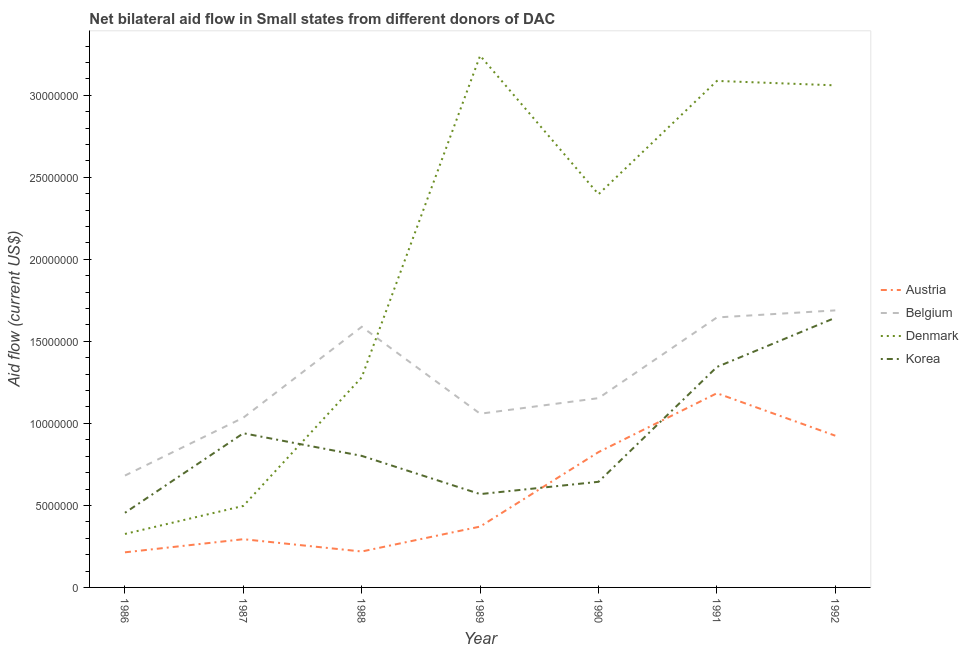Does the line corresponding to amount of aid given by korea intersect with the line corresponding to amount of aid given by austria?
Provide a short and direct response. Yes. What is the amount of aid given by korea in 1990?
Your answer should be very brief. 6.44e+06. Across all years, what is the maximum amount of aid given by belgium?
Your answer should be compact. 1.69e+07. Across all years, what is the minimum amount of aid given by belgium?
Provide a short and direct response. 6.82e+06. In which year was the amount of aid given by korea maximum?
Your answer should be compact. 1992. What is the total amount of aid given by austria in the graph?
Offer a very short reply. 4.03e+07. What is the difference between the amount of aid given by korea in 1988 and that in 1990?
Give a very brief answer. 1.58e+06. What is the difference between the amount of aid given by austria in 1989 and the amount of aid given by belgium in 1991?
Keep it short and to the point. -1.28e+07. What is the average amount of aid given by denmark per year?
Give a very brief answer. 1.98e+07. In the year 1989, what is the difference between the amount of aid given by austria and amount of aid given by korea?
Keep it short and to the point. -1.98e+06. In how many years, is the amount of aid given by korea greater than 25000000 US$?
Make the answer very short. 0. What is the ratio of the amount of aid given by austria in 1987 to that in 1991?
Your answer should be compact. 0.25. Is the amount of aid given by belgium in 1990 less than that in 1991?
Make the answer very short. Yes. What is the difference between the highest and the lowest amount of aid given by denmark?
Provide a short and direct response. 2.92e+07. In how many years, is the amount of aid given by korea greater than the average amount of aid given by korea taken over all years?
Provide a short and direct response. 3. Is it the case that in every year, the sum of the amount of aid given by belgium and amount of aid given by austria is greater than the sum of amount of aid given by korea and amount of aid given by denmark?
Your answer should be compact. No. Does the amount of aid given by denmark monotonically increase over the years?
Your answer should be very brief. No. Is the amount of aid given by belgium strictly greater than the amount of aid given by korea over the years?
Give a very brief answer. Yes. How many lines are there?
Your answer should be compact. 4. What is the difference between two consecutive major ticks on the Y-axis?
Provide a succinct answer. 5.00e+06. Does the graph contain any zero values?
Your response must be concise. No. Does the graph contain grids?
Your answer should be very brief. No. Where does the legend appear in the graph?
Make the answer very short. Center right. What is the title of the graph?
Your answer should be very brief. Net bilateral aid flow in Small states from different donors of DAC. Does "Rule based governance" appear as one of the legend labels in the graph?
Provide a short and direct response. No. What is the Aid flow (current US$) in Austria in 1986?
Your answer should be compact. 2.14e+06. What is the Aid flow (current US$) in Belgium in 1986?
Ensure brevity in your answer.  6.82e+06. What is the Aid flow (current US$) of Denmark in 1986?
Your answer should be very brief. 3.26e+06. What is the Aid flow (current US$) in Korea in 1986?
Ensure brevity in your answer.  4.55e+06. What is the Aid flow (current US$) of Austria in 1987?
Your response must be concise. 2.94e+06. What is the Aid flow (current US$) of Belgium in 1987?
Offer a very short reply. 1.04e+07. What is the Aid flow (current US$) of Denmark in 1987?
Make the answer very short. 4.97e+06. What is the Aid flow (current US$) of Korea in 1987?
Your response must be concise. 9.40e+06. What is the Aid flow (current US$) of Austria in 1988?
Ensure brevity in your answer.  2.19e+06. What is the Aid flow (current US$) in Belgium in 1988?
Provide a short and direct response. 1.59e+07. What is the Aid flow (current US$) in Denmark in 1988?
Provide a short and direct response. 1.28e+07. What is the Aid flow (current US$) of Korea in 1988?
Ensure brevity in your answer.  8.02e+06. What is the Aid flow (current US$) in Austria in 1989?
Give a very brief answer. 3.71e+06. What is the Aid flow (current US$) in Belgium in 1989?
Make the answer very short. 1.06e+07. What is the Aid flow (current US$) in Denmark in 1989?
Provide a short and direct response. 3.24e+07. What is the Aid flow (current US$) in Korea in 1989?
Make the answer very short. 5.69e+06. What is the Aid flow (current US$) in Austria in 1990?
Make the answer very short. 8.25e+06. What is the Aid flow (current US$) in Belgium in 1990?
Your response must be concise. 1.15e+07. What is the Aid flow (current US$) in Denmark in 1990?
Offer a terse response. 2.40e+07. What is the Aid flow (current US$) of Korea in 1990?
Your answer should be very brief. 6.44e+06. What is the Aid flow (current US$) of Austria in 1991?
Keep it short and to the point. 1.18e+07. What is the Aid flow (current US$) of Belgium in 1991?
Keep it short and to the point. 1.65e+07. What is the Aid flow (current US$) of Denmark in 1991?
Give a very brief answer. 3.09e+07. What is the Aid flow (current US$) in Korea in 1991?
Offer a terse response. 1.34e+07. What is the Aid flow (current US$) of Austria in 1992?
Keep it short and to the point. 9.25e+06. What is the Aid flow (current US$) in Belgium in 1992?
Your response must be concise. 1.69e+07. What is the Aid flow (current US$) in Denmark in 1992?
Your answer should be very brief. 3.06e+07. What is the Aid flow (current US$) of Korea in 1992?
Give a very brief answer. 1.64e+07. Across all years, what is the maximum Aid flow (current US$) in Austria?
Provide a succinct answer. 1.18e+07. Across all years, what is the maximum Aid flow (current US$) of Belgium?
Offer a very short reply. 1.69e+07. Across all years, what is the maximum Aid flow (current US$) of Denmark?
Keep it short and to the point. 3.24e+07. Across all years, what is the maximum Aid flow (current US$) in Korea?
Offer a very short reply. 1.64e+07. Across all years, what is the minimum Aid flow (current US$) of Austria?
Ensure brevity in your answer.  2.14e+06. Across all years, what is the minimum Aid flow (current US$) of Belgium?
Offer a very short reply. 6.82e+06. Across all years, what is the minimum Aid flow (current US$) in Denmark?
Make the answer very short. 3.26e+06. Across all years, what is the minimum Aid flow (current US$) of Korea?
Give a very brief answer. 4.55e+06. What is the total Aid flow (current US$) in Austria in the graph?
Make the answer very short. 4.03e+07. What is the total Aid flow (current US$) of Belgium in the graph?
Provide a succinct answer. 8.85e+07. What is the total Aid flow (current US$) in Denmark in the graph?
Ensure brevity in your answer.  1.39e+08. What is the total Aid flow (current US$) of Korea in the graph?
Make the answer very short. 6.40e+07. What is the difference between the Aid flow (current US$) in Austria in 1986 and that in 1987?
Keep it short and to the point. -8.00e+05. What is the difference between the Aid flow (current US$) in Belgium in 1986 and that in 1987?
Give a very brief answer. -3.53e+06. What is the difference between the Aid flow (current US$) of Denmark in 1986 and that in 1987?
Offer a terse response. -1.71e+06. What is the difference between the Aid flow (current US$) of Korea in 1986 and that in 1987?
Keep it short and to the point. -4.85e+06. What is the difference between the Aid flow (current US$) of Belgium in 1986 and that in 1988?
Provide a succinct answer. -9.07e+06. What is the difference between the Aid flow (current US$) of Denmark in 1986 and that in 1988?
Your answer should be compact. -9.55e+06. What is the difference between the Aid flow (current US$) of Korea in 1986 and that in 1988?
Keep it short and to the point. -3.47e+06. What is the difference between the Aid flow (current US$) of Austria in 1986 and that in 1989?
Provide a short and direct response. -1.57e+06. What is the difference between the Aid flow (current US$) of Belgium in 1986 and that in 1989?
Make the answer very short. -3.77e+06. What is the difference between the Aid flow (current US$) of Denmark in 1986 and that in 1989?
Offer a terse response. -2.92e+07. What is the difference between the Aid flow (current US$) in Korea in 1986 and that in 1989?
Offer a very short reply. -1.14e+06. What is the difference between the Aid flow (current US$) in Austria in 1986 and that in 1990?
Make the answer very short. -6.11e+06. What is the difference between the Aid flow (current US$) of Belgium in 1986 and that in 1990?
Offer a terse response. -4.72e+06. What is the difference between the Aid flow (current US$) of Denmark in 1986 and that in 1990?
Your response must be concise. -2.07e+07. What is the difference between the Aid flow (current US$) of Korea in 1986 and that in 1990?
Provide a succinct answer. -1.89e+06. What is the difference between the Aid flow (current US$) of Austria in 1986 and that in 1991?
Offer a terse response. -9.70e+06. What is the difference between the Aid flow (current US$) in Belgium in 1986 and that in 1991?
Ensure brevity in your answer.  -9.64e+06. What is the difference between the Aid flow (current US$) in Denmark in 1986 and that in 1991?
Provide a short and direct response. -2.76e+07. What is the difference between the Aid flow (current US$) of Korea in 1986 and that in 1991?
Give a very brief answer. -8.89e+06. What is the difference between the Aid flow (current US$) in Austria in 1986 and that in 1992?
Your answer should be compact. -7.11e+06. What is the difference between the Aid flow (current US$) in Belgium in 1986 and that in 1992?
Offer a terse response. -1.01e+07. What is the difference between the Aid flow (current US$) in Denmark in 1986 and that in 1992?
Your answer should be very brief. -2.74e+07. What is the difference between the Aid flow (current US$) of Korea in 1986 and that in 1992?
Make the answer very short. -1.19e+07. What is the difference between the Aid flow (current US$) of Austria in 1987 and that in 1988?
Provide a short and direct response. 7.50e+05. What is the difference between the Aid flow (current US$) in Belgium in 1987 and that in 1988?
Provide a short and direct response. -5.54e+06. What is the difference between the Aid flow (current US$) in Denmark in 1987 and that in 1988?
Offer a terse response. -7.84e+06. What is the difference between the Aid flow (current US$) in Korea in 1987 and that in 1988?
Ensure brevity in your answer.  1.38e+06. What is the difference between the Aid flow (current US$) in Austria in 1987 and that in 1989?
Your answer should be very brief. -7.70e+05. What is the difference between the Aid flow (current US$) in Belgium in 1987 and that in 1989?
Give a very brief answer. -2.40e+05. What is the difference between the Aid flow (current US$) of Denmark in 1987 and that in 1989?
Provide a succinct answer. -2.74e+07. What is the difference between the Aid flow (current US$) in Korea in 1987 and that in 1989?
Ensure brevity in your answer.  3.71e+06. What is the difference between the Aid flow (current US$) of Austria in 1987 and that in 1990?
Your response must be concise. -5.31e+06. What is the difference between the Aid flow (current US$) in Belgium in 1987 and that in 1990?
Make the answer very short. -1.19e+06. What is the difference between the Aid flow (current US$) in Denmark in 1987 and that in 1990?
Your answer should be compact. -1.90e+07. What is the difference between the Aid flow (current US$) in Korea in 1987 and that in 1990?
Keep it short and to the point. 2.96e+06. What is the difference between the Aid flow (current US$) in Austria in 1987 and that in 1991?
Make the answer very short. -8.90e+06. What is the difference between the Aid flow (current US$) of Belgium in 1987 and that in 1991?
Give a very brief answer. -6.11e+06. What is the difference between the Aid flow (current US$) in Denmark in 1987 and that in 1991?
Give a very brief answer. -2.59e+07. What is the difference between the Aid flow (current US$) of Korea in 1987 and that in 1991?
Keep it short and to the point. -4.04e+06. What is the difference between the Aid flow (current US$) of Austria in 1987 and that in 1992?
Your response must be concise. -6.31e+06. What is the difference between the Aid flow (current US$) of Belgium in 1987 and that in 1992?
Ensure brevity in your answer.  -6.54e+06. What is the difference between the Aid flow (current US$) of Denmark in 1987 and that in 1992?
Offer a terse response. -2.56e+07. What is the difference between the Aid flow (current US$) of Korea in 1987 and that in 1992?
Provide a succinct answer. -7.04e+06. What is the difference between the Aid flow (current US$) of Austria in 1988 and that in 1989?
Your response must be concise. -1.52e+06. What is the difference between the Aid flow (current US$) in Belgium in 1988 and that in 1989?
Your answer should be very brief. 5.30e+06. What is the difference between the Aid flow (current US$) in Denmark in 1988 and that in 1989?
Offer a terse response. -1.96e+07. What is the difference between the Aid flow (current US$) in Korea in 1988 and that in 1989?
Give a very brief answer. 2.33e+06. What is the difference between the Aid flow (current US$) of Austria in 1988 and that in 1990?
Make the answer very short. -6.06e+06. What is the difference between the Aid flow (current US$) in Belgium in 1988 and that in 1990?
Offer a terse response. 4.35e+06. What is the difference between the Aid flow (current US$) in Denmark in 1988 and that in 1990?
Ensure brevity in your answer.  -1.12e+07. What is the difference between the Aid flow (current US$) of Korea in 1988 and that in 1990?
Your response must be concise. 1.58e+06. What is the difference between the Aid flow (current US$) of Austria in 1988 and that in 1991?
Offer a terse response. -9.65e+06. What is the difference between the Aid flow (current US$) in Belgium in 1988 and that in 1991?
Keep it short and to the point. -5.70e+05. What is the difference between the Aid flow (current US$) in Denmark in 1988 and that in 1991?
Keep it short and to the point. -1.81e+07. What is the difference between the Aid flow (current US$) of Korea in 1988 and that in 1991?
Offer a terse response. -5.42e+06. What is the difference between the Aid flow (current US$) of Austria in 1988 and that in 1992?
Your answer should be very brief. -7.06e+06. What is the difference between the Aid flow (current US$) in Denmark in 1988 and that in 1992?
Your answer should be very brief. -1.78e+07. What is the difference between the Aid flow (current US$) of Korea in 1988 and that in 1992?
Keep it short and to the point. -8.42e+06. What is the difference between the Aid flow (current US$) in Austria in 1989 and that in 1990?
Provide a short and direct response. -4.54e+06. What is the difference between the Aid flow (current US$) in Belgium in 1989 and that in 1990?
Your response must be concise. -9.50e+05. What is the difference between the Aid flow (current US$) in Denmark in 1989 and that in 1990?
Ensure brevity in your answer.  8.45e+06. What is the difference between the Aid flow (current US$) in Korea in 1989 and that in 1990?
Provide a succinct answer. -7.50e+05. What is the difference between the Aid flow (current US$) in Austria in 1989 and that in 1991?
Ensure brevity in your answer.  -8.13e+06. What is the difference between the Aid flow (current US$) in Belgium in 1989 and that in 1991?
Offer a terse response. -5.87e+06. What is the difference between the Aid flow (current US$) of Denmark in 1989 and that in 1991?
Your response must be concise. 1.54e+06. What is the difference between the Aid flow (current US$) in Korea in 1989 and that in 1991?
Offer a very short reply. -7.75e+06. What is the difference between the Aid flow (current US$) in Austria in 1989 and that in 1992?
Your answer should be compact. -5.54e+06. What is the difference between the Aid flow (current US$) of Belgium in 1989 and that in 1992?
Your answer should be very brief. -6.30e+06. What is the difference between the Aid flow (current US$) of Denmark in 1989 and that in 1992?
Make the answer very short. 1.81e+06. What is the difference between the Aid flow (current US$) of Korea in 1989 and that in 1992?
Ensure brevity in your answer.  -1.08e+07. What is the difference between the Aid flow (current US$) in Austria in 1990 and that in 1991?
Offer a very short reply. -3.59e+06. What is the difference between the Aid flow (current US$) in Belgium in 1990 and that in 1991?
Your response must be concise. -4.92e+06. What is the difference between the Aid flow (current US$) in Denmark in 1990 and that in 1991?
Your answer should be compact. -6.91e+06. What is the difference between the Aid flow (current US$) of Korea in 1990 and that in 1991?
Keep it short and to the point. -7.00e+06. What is the difference between the Aid flow (current US$) in Austria in 1990 and that in 1992?
Provide a succinct answer. -1.00e+06. What is the difference between the Aid flow (current US$) of Belgium in 1990 and that in 1992?
Your answer should be compact. -5.35e+06. What is the difference between the Aid flow (current US$) in Denmark in 1990 and that in 1992?
Provide a short and direct response. -6.64e+06. What is the difference between the Aid flow (current US$) in Korea in 1990 and that in 1992?
Provide a succinct answer. -1.00e+07. What is the difference between the Aid flow (current US$) of Austria in 1991 and that in 1992?
Your response must be concise. 2.59e+06. What is the difference between the Aid flow (current US$) of Belgium in 1991 and that in 1992?
Provide a short and direct response. -4.30e+05. What is the difference between the Aid flow (current US$) of Denmark in 1991 and that in 1992?
Give a very brief answer. 2.70e+05. What is the difference between the Aid flow (current US$) in Korea in 1991 and that in 1992?
Make the answer very short. -3.00e+06. What is the difference between the Aid flow (current US$) of Austria in 1986 and the Aid flow (current US$) of Belgium in 1987?
Ensure brevity in your answer.  -8.21e+06. What is the difference between the Aid flow (current US$) of Austria in 1986 and the Aid flow (current US$) of Denmark in 1987?
Give a very brief answer. -2.83e+06. What is the difference between the Aid flow (current US$) of Austria in 1986 and the Aid flow (current US$) of Korea in 1987?
Make the answer very short. -7.26e+06. What is the difference between the Aid flow (current US$) in Belgium in 1986 and the Aid flow (current US$) in Denmark in 1987?
Give a very brief answer. 1.85e+06. What is the difference between the Aid flow (current US$) of Belgium in 1986 and the Aid flow (current US$) of Korea in 1987?
Provide a short and direct response. -2.58e+06. What is the difference between the Aid flow (current US$) of Denmark in 1986 and the Aid flow (current US$) of Korea in 1987?
Offer a very short reply. -6.14e+06. What is the difference between the Aid flow (current US$) in Austria in 1986 and the Aid flow (current US$) in Belgium in 1988?
Make the answer very short. -1.38e+07. What is the difference between the Aid flow (current US$) of Austria in 1986 and the Aid flow (current US$) of Denmark in 1988?
Keep it short and to the point. -1.07e+07. What is the difference between the Aid flow (current US$) in Austria in 1986 and the Aid flow (current US$) in Korea in 1988?
Give a very brief answer. -5.88e+06. What is the difference between the Aid flow (current US$) in Belgium in 1986 and the Aid flow (current US$) in Denmark in 1988?
Ensure brevity in your answer.  -5.99e+06. What is the difference between the Aid flow (current US$) in Belgium in 1986 and the Aid flow (current US$) in Korea in 1988?
Your answer should be compact. -1.20e+06. What is the difference between the Aid flow (current US$) of Denmark in 1986 and the Aid flow (current US$) of Korea in 1988?
Your response must be concise. -4.76e+06. What is the difference between the Aid flow (current US$) in Austria in 1986 and the Aid flow (current US$) in Belgium in 1989?
Give a very brief answer. -8.45e+06. What is the difference between the Aid flow (current US$) in Austria in 1986 and the Aid flow (current US$) in Denmark in 1989?
Make the answer very short. -3.03e+07. What is the difference between the Aid flow (current US$) in Austria in 1986 and the Aid flow (current US$) in Korea in 1989?
Provide a short and direct response. -3.55e+06. What is the difference between the Aid flow (current US$) of Belgium in 1986 and the Aid flow (current US$) of Denmark in 1989?
Keep it short and to the point. -2.56e+07. What is the difference between the Aid flow (current US$) in Belgium in 1986 and the Aid flow (current US$) in Korea in 1989?
Keep it short and to the point. 1.13e+06. What is the difference between the Aid flow (current US$) of Denmark in 1986 and the Aid flow (current US$) of Korea in 1989?
Give a very brief answer. -2.43e+06. What is the difference between the Aid flow (current US$) in Austria in 1986 and the Aid flow (current US$) in Belgium in 1990?
Offer a terse response. -9.40e+06. What is the difference between the Aid flow (current US$) of Austria in 1986 and the Aid flow (current US$) of Denmark in 1990?
Your answer should be very brief. -2.18e+07. What is the difference between the Aid flow (current US$) in Austria in 1986 and the Aid flow (current US$) in Korea in 1990?
Provide a succinct answer. -4.30e+06. What is the difference between the Aid flow (current US$) of Belgium in 1986 and the Aid flow (current US$) of Denmark in 1990?
Provide a short and direct response. -1.72e+07. What is the difference between the Aid flow (current US$) in Belgium in 1986 and the Aid flow (current US$) in Korea in 1990?
Your response must be concise. 3.80e+05. What is the difference between the Aid flow (current US$) in Denmark in 1986 and the Aid flow (current US$) in Korea in 1990?
Your answer should be very brief. -3.18e+06. What is the difference between the Aid flow (current US$) of Austria in 1986 and the Aid flow (current US$) of Belgium in 1991?
Your response must be concise. -1.43e+07. What is the difference between the Aid flow (current US$) in Austria in 1986 and the Aid flow (current US$) in Denmark in 1991?
Make the answer very short. -2.87e+07. What is the difference between the Aid flow (current US$) of Austria in 1986 and the Aid flow (current US$) of Korea in 1991?
Keep it short and to the point. -1.13e+07. What is the difference between the Aid flow (current US$) in Belgium in 1986 and the Aid flow (current US$) in Denmark in 1991?
Your response must be concise. -2.41e+07. What is the difference between the Aid flow (current US$) of Belgium in 1986 and the Aid flow (current US$) of Korea in 1991?
Provide a short and direct response. -6.62e+06. What is the difference between the Aid flow (current US$) in Denmark in 1986 and the Aid flow (current US$) in Korea in 1991?
Give a very brief answer. -1.02e+07. What is the difference between the Aid flow (current US$) of Austria in 1986 and the Aid flow (current US$) of Belgium in 1992?
Provide a short and direct response. -1.48e+07. What is the difference between the Aid flow (current US$) in Austria in 1986 and the Aid flow (current US$) in Denmark in 1992?
Your answer should be very brief. -2.85e+07. What is the difference between the Aid flow (current US$) in Austria in 1986 and the Aid flow (current US$) in Korea in 1992?
Give a very brief answer. -1.43e+07. What is the difference between the Aid flow (current US$) of Belgium in 1986 and the Aid flow (current US$) of Denmark in 1992?
Provide a succinct answer. -2.38e+07. What is the difference between the Aid flow (current US$) in Belgium in 1986 and the Aid flow (current US$) in Korea in 1992?
Make the answer very short. -9.62e+06. What is the difference between the Aid flow (current US$) in Denmark in 1986 and the Aid flow (current US$) in Korea in 1992?
Provide a short and direct response. -1.32e+07. What is the difference between the Aid flow (current US$) of Austria in 1987 and the Aid flow (current US$) of Belgium in 1988?
Give a very brief answer. -1.30e+07. What is the difference between the Aid flow (current US$) in Austria in 1987 and the Aid flow (current US$) in Denmark in 1988?
Ensure brevity in your answer.  -9.87e+06. What is the difference between the Aid flow (current US$) of Austria in 1987 and the Aid flow (current US$) of Korea in 1988?
Provide a succinct answer. -5.08e+06. What is the difference between the Aid flow (current US$) in Belgium in 1987 and the Aid flow (current US$) in Denmark in 1988?
Your answer should be very brief. -2.46e+06. What is the difference between the Aid flow (current US$) of Belgium in 1987 and the Aid flow (current US$) of Korea in 1988?
Provide a succinct answer. 2.33e+06. What is the difference between the Aid flow (current US$) of Denmark in 1987 and the Aid flow (current US$) of Korea in 1988?
Your response must be concise. -3.05e+06. What is the difference between the Aid flow (current US$) in Austria in 1987 and the Aid flow (current US$) in Belgium in 1989?
Make the answer very short. -7.65e+06. What is the difference between the Aid flow (current US$) in Austria in 1987 and the Aid flow (current US$) in Denmark in 1989?
Your answer should be compact. -2.95e+07. What is the difference between the Aid flow (current US$) of Austria in 1987 and the Aid flow (current US$) of Korea in 1989?
Provide a short and direct response. -2.75e+06. What is the difference between the Aid flow (current US$) in Belgium in 1987 and the Aid flow (current US$) in Denmark in 1989?
Your response must be concise. -2.21e+07. What is the difference between the Aid flow (current US$) in Belgium in 1987 and the Aid flow (current US$) in Korea in 1989?
Keep it short and to the point. 4.66e+06. What is the difference between the Aid flow (current US$) of Denmark in 1987 and the Aid flow (current US$) of Korea in 1989?
Ensure brevity in your answer.  -7.20e+05. What is the difference between the Aid flow (current US$) in Austria in 1987 and the Aid flow (current US$) in Belgium in 1990?
Keep it short and to the point. -8.60e+06. What is the difference between the Aid flow (current US$) of Austria in 1987 and the Aid flow (current US$) of Denmark in 1990?
Keep it short and to the point. -2.10e+07. What is the difference between the Aid flow (current US$) of Austria in 1987 and the Aid flow (current US$) of Korea in 1990?
Make the answer very short. -3.50e+06. What is the difference between the Aid flow (current US$) of Belgium in 1987 and the Aid flow (current US$) of Denmark in 1990?
Keep it short and to the point. -1.36e+07. What is the difference between the Aid flow (current US$) of Belgium in 1987 and the Aid flow (current US$) of Korea in 1990?
Your response must be concise. 3.91e+06. What is the difference between the Aid flow (current US$) of Denmark in 1987 and the Aid flow (current US$) of Korea in 1990?
Ensure brevity in your answer.  -1.47e+06. What is the difference between the Aid flow (current US$) in Austria in 1987 and the Aid flow (current US$) in Belgium in 1991?
Give a very brief answer. -1.35e+07. What is the difference between the Aid flow (current US$) in Austria in 1987 and the Aid flow (current US$) in Denmark in 1991?
Keep it short and to the point. -2.79e+07. What is the difference between the Aid flow (current US$) of Austria in 1987 and the Aid flow (current US$) of Korea in 1991?
Keep it short and to the point. -1.05e+07. What is the difference between the Aid flow (current US$) of Belgium in 1987 and the Aid flow (current US$) of Denmark in 1991?
Offer a very short reply. -2.05e+07. What is the difference between the Aid flow (current US$) of Belgium in 1987 and the Aid flow (current US$) of Korea in 1991?
Provide a succinct answer. -3.09e+06. What is the difference between the Aid flow (current US$) of Denmark in 1987 and the Aid flow (current US$) of Korea in 1991?
Make the answer very short. -8.47e+06. What is the difference between the Aid flow (current US$) of Austria in 1987 and the Aid flow (current US$) of Belgium in 1992?
Your answer should be compact. -1.40e+07. What is the difference between the Aid flow (current US$) in Austria in 1987 and the Aid flow (current US$) in Denmark in 1992?
Your answer should be compact. -2.77e+07. What is the difference between the Aid flow (current US$) of Austria in 1987 and the Aid flow (current US$) of Korea in 1992?
Your response must be concise. -1.35e+07. What is the difference between the Aid flow (current US$) of Belgium in 1987 and the Aid flow (current US$) of Denmark in 1992?
Your answer should be compact. -2.03e+07. What is the difference between the Aid flow (current US$) in Belgium in 1987 and the Aid flow (current US$) in Korea in 1992?
Your response must be concise. -6.09e+06. What is the difference between the Aid flow (current US$) in Denmark in 1987 and the Aid flow (current US$) in Korea in 1992?
Ensure brevity in your answer.  -1.15e+07. What is the difference between the Aid flow (current US$) in Austria in 1988 and the Aid flow (current US$) in Belgium in 1989?
Offer a very short reply. -8.40e+06. What is the difference between the Aid flow (current US$) in Austria in 1988 and the Aid flow (current US$) in Denmark in 1989?
Keep it short and to the point. -3.02e+07. What is the difference between the Aid flow (current US$) of Austria in 1988 and the Aid flow (current US$) of Korea in 1989?
Give a very brief answer. -3.50e+06. What is the difference between the Aid flow (current US$) in Belgium in 1988 and the Aid flow (current US$) in Denmark in 1989?
Offer a very short reply. -1.65e+07. What is the difference between the Aid flow (current US$) in Belgium in 1988 and the Aid flow (current US$) in Korea in 1989?
Give a very brief answer. 1.02e+07. What is the difference between the Aid flow (current US$) of Denmark in 1988 and the Aid flow (current US$) of Korea in 1989?
Keep it short and to the point. 7.12e+06. What is the difference between the Aid flow (current US$) in Austria in 1988 and the Aid flow (current US$) in Belgium in 1990?
Offer a terse response. -9.35e+06. What is the difference between the Aid flow (current US$) in Austria in 1988 and the Aid flow (current US$) in Denmark in 1990?
Give a very brief answer. -2.18e+07. What is the difference between the Aid flow (current US$) of Austria in 1988 and the Aid flow (current US$) of Korea in 1990?
Your answer should be very brief. -4.25e+06. What is the difference between the Aid flow (current US$) in Belgium in 1988 and the Aid flow (current US$) in Denmark in 1990?
Make the answer very short. -8.08e+06. What is the difference between the Aid flow (current US$) in Belgium in 1988 and the Aid flow (current US$) in Korea in 1990?
Offer a very short reply. 9.45e+06. What is the difference between the Aid flow (current US$) of Denmark in 1988 and the Aid flow (current US$) of Korea in 1990?
Your answer should be compact. 6.37e+06. What is the difference between the Aid flow (current US$) in Austria in 1988 and the Aid flow (current US$) in Belgium in 1991?
Your answer should be compact. -1.43e+07. What is the difference between the Aid flow (current US$) in Austria in 1988 and the Aid flow (current US$) in Denmark in 1991?
Make the answer very short. -2.87e+07. What is the difference between the Aid flow (current US$) in Austria in 1988 and the Aid flow (current US$) in Korea in 1991?
Your response must be concise. -1.12e+07. What is the difference between the Aid flow (current US$) in Belgium in 1988 and the Aid flow (current US$) in Denmark in 1991?
Your answer should be compact. -1.50e+07. What is the difference between the Aid flow (current US$) in Belgium in 1988 and the Aid flow (current US$) in Korea in 1991?
Give a very brief answer. 2.45e+06. What is the difference between the Aid flow (current US$) in Denmark in 1988 and the Aid flow (current US$) in Korea in 1991?
Offer a very short reply. -6.30e+05. What is the difference between the Aid flow (current US$) in Austria in 1988 and the Aid flow (current US$) in Belgium in 1992?
Your response must be concise. -1.47e+07. What is the difference between the Aid flow (current US$) of Austria in 1988 and the Aid flow (current US$) of Denmark in 1992?
Keep it short and to the point. -2.84e+07. What is the difference between the Aid flow (current US$) in Austria in 1988 and the Aid flow (current US$) in Korea in 1992?
Make the answer very short. -1.42e+07. What is the difference between the Aid flow (current US$) in Belgium in 1988 and the Aid flow (current US$) in Denmark in 1992?
Give a very brief answer. -1.47e+07. What is the difference between the Aid flow (current US$) of Belgium in 1988 and the Aid flow (current US$) of Korea in 1992?
Make the answer very short. -5.50e+05. What is the difference between the Aid flow (current US$) of Denmark in 1988 and the Aid flow (current US$) of Korea in 1992?
Your answer should be compact. -3.63e+06. What is the difference between the Aid flow (current US$) in Austria in 1989 and the Aid flow (current US$) in Belgium in 1990?
Your answer should be compact. -7.83e+06. What is the difference between the Aid flow (current US$) of Austria in 1989 and the Aid flow (current US$) of Denmark in 1990?
Your response must be concise. -2.03e+07. What is the difference between the Aid flow (current US$) of Austria in 1989 and the Aid flow (current US$) of Korea in 1990?
Your answer should be very brief. -2.73e+06. What is the difference between the Aid flow (current US$) in Belgium in 1989 and the Aid flow (current US$) in Denmark in 1990?
Give a very brief answer. -1.34e+07. What is the difference between the Aid flow (current US$) of Belgium in 1989 and the Aid flow (current US$) of Korea in 1990?
Give a very brief answer. 4.15e+06. What is the difference between the Aid flow (current US$) of Denmark in 1989 and the Aid flow (current US$) of Korea in 1990?
Give a very brief answer. 2.60e+07. What is the difference between the Aid flow (current US$) of Austria in 1989 and the Aid flow (current US$) of Belgium in 1991?
Your answer should be very brief. -1.28e+07. What is the difference between the Aid flow (current US$) of Austria in 1989 and the Aid flow (current US$) of Denmark in 1991?
Provide a short and direct response. -2.72e+07. What is the difference between the Aid flow (current US$) in Austria in 1989 and the Aid flow (current US$) in Korea in 1991?
Give a very brief answer. -9.73e+06. What is the difference between the Aid flow (current US$) of Belgium in 1989 and the Aid flow (current US$) of Denmark in 1991?
Your response must be concise. -2.03e+07. What is the difference between the Aid flow (current US$) in Belgium in 1989 and the Aid flow (current US$) in Korea in 1991?
Your response must be concise. -2.85e+06. What is the difference between the Aid flow (current US$) of Denmark in 1989 and the Aid flow (current US$) of Korea in 1991?
Make the answer very short. 1.90e+07. What is the difference between the Aid flow (current US$) in Austria in 1989 and the Aid flow (current US$) in Belgium in 1992?
Make the answer very short. -1.32e+07. What is the difference between the Aid flow (current US$) of Austria in 1989 and the Aid flow (current US$) of Denmark in 1992?
Your answer should be compact. -2.69e+07. What is the difference between the Aid flow (current US$) of Austria in 1989 and the Aid flow (current US$) of Korea in 1992?
Offer a very short reply. -1.27e+07. What is the difference between the Aid flow (current US$) in Belgium in 1989 and the Aid flow (current US$) in Denmark in 1992?
Your answer should be very brief. -2.00e+07. What is the difference between the Aid flow (current US$) in Belgium in 1989 and the Aid flow (current US$) in Korea in 1992?
Your answer should be compact. -5.85e+06. What is the difference between the Aid flow (current US$) in Denmark in 1989 and the Aid flow (current US$) in Korea in 1992?
Ensure brevity in your answer.  1.60e+07. What is the difference between the Aid flow (current US$) in Austria in 1990 and the Aid flow (current US$) in Belgium in 1991?
Keep it short and to the point. -8.21e+06. What is the difference between the Aid flow (current US$) of Austria in 1990 and the Aid flow (current US$) of Denmark in 1991?
Give a very brief answer. -2.26e+07. What is the difference between the Aid flow (current US$) in Austria in 1990 and the Aid flow (current US$) in Korea in 1991?
Give a very brief answer. -5.19e+06. What is the difference between the Aid flow (current US$) of Belgium in 1990 and the Aid flow (current US$) of Denmark in 1991?
Give a very brief answer. -1.93e+07. What is the difference between the Aid flow (current US$) of Belgium in 1990 and the Aid flow (current US$) of Korea in 1991?
Keep it short and to the point. -1.90e+06. What is the difference between the Aid flow (current US$) of Denmark in 1990 and the Aid flow (current US$) of Korea in 1991?
Your answer should be very brief. 1.05e+07. What is the difference between the Aid flow (current US$) in Austria in 1990 and the Aid flow (current US$) in Belgium in 1992?
Give a very brief answer. -8.64e+06. What is the difference between the Aid flow (current US$) in Austria in 1990 and the Aid flow (current US$) in Denmark in 1992?
Provide a short and direct response. -2.24e+07. What is the difference between the Aid flow (current US$) of Austria in 1990 and the Aid flow (current US$) of Korea in 1992?
Your response must be concise. -8.19e+06. What is the difference between the Aid flow (current US$) in Belgium in 1990 and the Aid flow (current US$) in Denmark in 1992?
Make the answer very short. -1.91e+07. What is the difference between the Aid flow (current US$) of Belgium in 1990 and the Aid flow (current US$) of Korea in 1992?
Offer a terse response. -4.90e+06. What is the difference between the Aid flow (current US$) of Denmark in 1990 and the Aid flow (current US$) of Korea in 1992?
Keep it short and to the point. 7.53e+06. What is the difference between the Aid flow (current US$) in Austria in 1991 and the Aid flow (current US$) in Belgium in 1992?
Provide a short and direct response. -5.05e+06. What is the difference between the Aid flow (current US$) in Austria in 1991 and the Aid flow (current US$) in Denmark in 1992?
Make the answer very short. -1.88e+07. What is the difference between the Aid flow (current US$) of Austria in 1991 and the Aid flow (current US$) of Korea in 1992?
Give a very brief answer. -4.60e+06. What is the difference between the Aid flow (current US$) in Belgium in 1991 and the Aid flow (current US$) in Denmark in 1992?
Provide a succinct answer. -1.42e+07. What is the difference between the Aid flow (current US$) in Belgium in 1991 and the Aid flow (current US$) in Korea in 1992?
Make the answer very short. 2.00e+04. What is the difference between the Aid flow (current US$) in Denmark in 1991 and the Aid flow (current US$) in Korea in 1992?
Provide a short and direct response. 1.44e+07. What is the average Aid flow (current US$) of Austria per year?
Your answer should be very brief. 5.76e+06. What is the average Aid flow (current US$) of Belgium per year?
Your answer should be compact. 1.26e+07. What is the average Aid flow (current US$) of Denmark per year?
Keep it short and to the point. 1.98e+07. What is the average Aid flow (current US$) in Korea per year?
Offer a terse response. 9.14e+06. In the year 1986, what is the difference between the Aid flow (current US$) of Austria and Aid flow (current US$) of Belgium?
Make the answer very short. -4.68e+06. In the year 1986, what is the difference between the Aid flow (current US$) in Austria and Aid flow (current US$) in Denmark?
Give a very brief answer. -1.12e+06. In the year 1986, what is the difference between the Aid flow (current US$) in Austria and Aid flow (current US$) in Korea?
Your answer should be very brief. -2.41e+06. In the year 1986, what is the difference between the Aid flow (current US$) of Belgium and Aid flow (current US$) of Denmark?
Provide a short and direct response. 3.56e+06. In the year 1986, what is the difference between the Aid flow (current US$) in Belgium and Aid flow (current US$) in Korea?
Give a very brief answer. 2.27e+06. In the year 1986, what is the difference between the Aid flow (current US$) in Denmark and Aid flow (current US$) in Korea?
Your response must be concise. -1.29e+06. In the year 1987, what is the difference between the Aid flow (current US$) in Austria and Aid flow (current US$) in Belgium?
Provide a succinct answer. -7.41e+06. In the year 1987, what is the difference between the Aid flow (current US$) in Austria and Aid flow (current US$) in Denmark?
Keep it short and to the point. -2.03e+06. In the year 1987, what is the difference between the Aid flow (current US$) in Austria and Aid flow (current US$) in Korea?
Your response must be concise. -6.46e+06. In the year 1987, what is the difference between the Aid flow (current US$) of Belgium and Aid flow (current US$) of Denmark?
Provide a short and direct response. 5.38e+06. In the year 1987, what is the difference between the Aid flow (current US$) of Belgium and Aid flow (current US$) of Korea?
Your answer should be very brief. 9.50e+05. In the year 1987, what is the difference between the Aid flow (current US$) of Denmark and Aid flow (current US$) of Korea?
Your answer should be compact. -4.43e+06. In the year 1988, what is the difference between the Aid flow (current US$) in Austria and Aid flow (current US$) in Belgium?
Ensure brevity in your answer.  -1.37e+07. In the year 1988, what is the difference between the Aid flow (current US$) of Austria and Aid flow (current US$) of Denmark?
Offer a terse response. -1.06e+07. In the year 1988, what is the difference between the Aid flow (current US$) in Austria and Aid flow (current US$) in Korea?
Provide a short and direct response. -5.83e+06. In the year 1988, what is the difference between the Aid flow (current US$) in Belgium and Aid flow (current US$) in Denmark?
Your answer should be compact. 3.08e+06. In the year 1988, what is the difference between the Aid flow (current US$) in Belgium and Aid flow (current US$) in Korea?
Your response must be concise. 7.87e+06. In the year 1988, what is the difference between the Aid flow (current US$) of Denmark and Aid flow (current US$) of Korea?
Your answer should be very brief. 4.79e+06. In the year 1989, what is the difference between the Aid flow (current US$) of Austria and Aid flow (current US$) of Belgium?
Keep it short and to the point. -6.88e+06. In the year 1989, what is the difference between the Aid flow (current US$) in Austria and Aid flow (current US$) in Denmark?
Your response must be concise. -2.87e+07. In the year 1989, what is the difference between the Aid flow (current US$) in Austria and Aid flow (current US$) in Korea?
Keep it short and to the point. -1.98e+06. In the year 1989, what is the difference between the Aid flow (current US$) in Belgium and Aid flow (current US$) in Denmark?
Offer a terse response. -2.18e+07. In the year 1989, what is the difference between the Aid flow (current US$) in Belgium and Aid flow (current US$) in Korea?
Keep it short and to the point. 4.90e+06. In the year 1989, what is the difference between the Aid flow (current US$) of Denmark and Aid flow (current US$) of Korea?
Your answer should be compact. 2.67e+07. In the year 1990, what is the difference between the Aid flow (current US$) in Austria and Aid flow (current US$) in Belgium?
Keep it short and to the point. -3.29e+06. In the year 1990, what is the difference between the Aid flow (current US$) of Austria and Aid flow (current US$) of Denmark?
Offer a very short reply. -1.57e+07. In the year 1990, what is the difference between the Aid flow (current US$) of Austria and Aid flow (current US$) of Korea?
Give a very brief answer. 1.81e+06. In the year 1990, what is the difference between the Aid flow (current US$) of Belgium and Aid flow (current US$) of Denmark?
Keep it short and to the point. -1.24e+07. In the year 1990, what is the difference between the Aid flow (current US$) in Belgium and Aid flow (current US$) in Korea?
Offer a terse response. 5.10e+06. In the year 1990, what is the difference between the Aid flow (current US$) of Denmark and Aid flow (current US$) of Korea?
Keep it short and to the point. 1.75e+07. In the year 1991, what is the difference between the Aid flow (current US$) in Austria and Aid flow (current US$) in Belgium?
Your response must be concise. -4.62e+06. In the year 1991, what is the difference between the Aid flow (current US$) of Austria and Aid flow (current US$) of Denmark?
Your answer should be very brief. -1.90e+07. In the year 1991, what is the difference between the Aid flow (current US$) of Austria and Aid flow (current US$) of Korea?
Keep it short and to the point. -1.60e+06. In the year 1991, what is the difference between the Aid flow (current US$) of Belgium and Aid flow (current US$) of Denmark?
Offer a terse response. -1.44e+07. In the year 1991, what is the difference between the Aid flow (current US$) in Belgium and Aid flow (current US$) in Korea?
Make the answer very short. 3.02e+06. In the year 1991, what is the difference between the Aid flow (current US$) in Denmark and Aid flow (current US$) in Korea?
Your response must be concise. 1.74e+07. In the year 1992, what is the difference between the Aid flow (current US$) of Austria and Aid flow (current US$) of Belgium?
Your answer should be very brief. -7.64e+06. In the year 1992, what is the difference between the Aid flow (current US$) in Austria and Aid flow (current US$) in Denmark?
Your answer should be compact. -2.14e+07. In the year 1992, what is the difference between the Aid flow (current US$) of Austria and Aid flow (current US$) of Korea?
Your answer should be very brief. -7.19e+06. In the year 1992, what is the difference between the Aid flow (current US$) of Belgium and Aid flow (current US$) of Denmark?
Your answer should be compact. -1.37e+07. In the year 1992, what is the difference between the Aid flow (current US$) of Denmark and Aid flow (current US$) of Korea?
Your answer should be compact. 1.42e+07. What is the ratio of the Aid flow (current US$) in Austria in 1986 to that in 1987?
Your response must be concise. 0.73. What is the ratio of the Aid flow (current US$) in Belgium in 1986 to that in 1987?
Give a very brief answer. 0.66. What is the ratio of the Aid flow (current US$) of Denmark in 1986 to that in 1987?
Keep it short and to the point. 0.66. What is the ratio of the Aid flow (current US$) of Korea in 1986 to that in 1987?
Give a very brief answer. 0.48. What is the ratio of the Aid flow (current US$) in Austria in 1986 to that in 1988?
Give a very brief answer. 0.98. What is the ratio of the Aid flow (current US$) of Belgium in 1986 to that in 1988?
Provide a succinct answer. 0.43. What is the ratio of the Aid flow (current US$) in Denmark in 1986 to that in 1988?
Provide a short and direct response. 0.25. What is the ratio of the Aid flow (current US$) in Korea in 1986 to that in 1988?
Provide a short and direct response. 0.57. What is the ratio of the Aid flow (current US$) in Austria in 1986 to that in 1989?
Give a very brief answer. 0.58. What is the ratio of the Aid flow (current US$) of Belgium in 1986 to that in 1989?
Offer a very short reply. 0.64. What is the ratio of the Aid flow (current US$) of Denmark in 1986 to that in 1989?
Your answer should be very brief. 0.1. What is the ratio of the Aid flow (current US$) in Korea in 1986 to that in 1989?
Provide a short and direct response. 0.8. What is the ratio of the Aid flow (current US$) of Austria in 1986 to that in 1990?
Your answer should be very brief. 0.26. What is the ratio of the Aid flow (current US$) in Belgium in 1986 to that in 1990?
Your response must be concise. 0.59. What is the ratio of the Aid flow (current US$) in Denmark in 1986 to that in 1990?
Your response must be concise. 0.14. What is the ratio of the Aid flow (current US$) of Korea in 1986 to that in 1990?
Give a very brief answer. 0.71. What is the ratio of the Aid flow (current US$) in Austria in 1986 to that in 1991?
Your answer should be very brief. 0.18. What is the ratio of the Aid flow (current US$) of Belgium in 1986 to that in 1991?
Provide a succinct answer. 0.41. What is the ratio of the Aid flow (current US$) in Denmark in 1986 to that in 1991?
Your answer should be compact. 0.11. What is the ratio of the Aid flow (current US$) in Korea in 1986 to that in 1991?
Keep it short and to the point. 0.34. What is the ratio of the Aid flow (current US$) in Austria in 1986 to that in 1992?
Your answer should be compact. 0.23. What is the ratio of the Aid flow (current US$) in Belgium in 1986 to that in 1992?
Your answer should be very brief. 0.4. What is the ratio of the Aid flow (current US$) in Denmark in 1986 to that in 1992?
Your answer should be compact. 0.11. What is the ratio of the Aid flow (current US$) in Korea in 1986 to that in 1992?
Make the answer very short. 0.28. What is the ratio of the Aid flow (current US$) in Austria in 1987 to that in 1988?
Keep it short and to the point. 1.34. What is the ratio of the Aid flow (current US$) of Belgium in 1987 to that in 1988?
Keep it short and to the point. 0.65. What is the ratio of the Aid flow (current US$) in Denmark in 1987 to that in 1988?
Ensure brevity in your answer.  0.39. What is the ratio of the Aid flow (current US$) in Korea in 1987 to that in 1988?
Offer a very short reply. 1.17. What is the ratio of the Aid flow (current US$) of Austria in 1987 to that in 1989?
Ensure brevity in your answer.  0.79. What is the ratio of the Aid flow (current US$) of Belgium in 1987 to that in 1989?
Provide a succinct answer. 0.98. What is the ratio of the Aid flow (current US$) in Denmark in 1987 to that in 1989?
Offer a terse response. 0.15. What is the ratio of the Aid flow (current US$) of Korea in 1987 to that in 1989?
Your response must be concise. 1.65. What is the ratio of the Aid flow (current US$) of Austria in 1987 to that in 1990?
Offer a very short reply. 0.36. What is the ratio of the Aid flow (current US$) in Belgium in 1987 to that in 1990?
Provide a succinct answer. 0.9. What is the ratio of the Aid flow (current US$) of Denmark in 1987 to that in 1990?
Provide a succinct answer. 0.21. What is the ratio of the Aid flow (current US$) of Korea in 1987 to that in 1990?
Keep it short and to the point. 1.46. What is the ratio of the Aid flow (current US$) of Austria in 1987 to that in 1991?
Keep it short and to the point. 0.25. What is the ratio of the Aid flow (current US$) in Belgium in 1987 to that in 1991?
Your answer should be very brief. 0.63. What is the ratio of the Aid flow (current US$) in Denmark in 1987 to that in 1991?
Your answer should be very brief. 0.16. What is the ratio of the Aid flow (current US$) in Korea in 1987 to that in 1991?
Offer a very short reply. 0.7. What is the ratio of the Aid flow (current US$) in Austria in 1987 to that in 1992?
Make the answer very short. 0.32. What is the ratio of the Aid flow (current US$) of Belgium in 1987 to that in 1992?
Your answer should be very brief. 0.61. What is the ratio of the Aid flow (current US$) in Denmark in 1987 to that in 1992?
Keep it short and to the point. 0.16. What is the ratio of the Aid flow (current US$) of Korea in 1987 to that in 1992?
Make the answer very short. 0.57. What is the ratio of the Aid flow (current US$) in Austria in 1988 to that in 1989?
Provide a short and direct response. 0.59. What is the ratio of the Aid flow (current US$) in Belgium in 1988 to that in 1989?
Provide a succinct answer. 1.5. What is the ratio of the Aid flow (current US$) in Denmark in 1988 to that in 1989?
Make the answer very short. 0.4. What is the ratio of the Aid flow (current US$) in Korea in 1988 to that in 1989?
Give a very brief answer. 1.41. What is the ratio of the Aid flow (current US$) of Austria in 1988 to that in 1990?
Offer a terse response. 0.27. What is the ratio of the Aid flow (current US$) of Belgium in 1988 to that in 1990?
Make the answer very short. 1.38. What is the ratio of the Aid flow (current US$) in Denmark in 1988 to that in 1990?
Ensure brevity in your answer.  0.53. What is the ratio of the Aid flow (current US$) of Korea in 1988 to that in 1990?
Provide a short and direct response. 1.25. What is the ratio of the Aid flow (current US$) of Austria in 1988 to that in 1991?
Offer a very short reply. 0.18. What is the ratio of the Aid flow (current US$) in Belgium in 1988 to that in 1991?
Your answer should be very brief. 0.97. What is the ratio of the Aid flow (current US$) in Denmark in 1988 to that in 1991?
Provide a short and direct response. 0.41. What is the ratio of the Aid flow (current US$) of Korea in 1988 to that in 1991?
Your response must be concise. 0.6. What is the ratio of the Aid flow (current US$) in Austria in 1988 to that in 1992?
Provide a short and direct response. 0.24. What is the ratio of the Aid flow (current US$) of Belgium in 1988 to that in 1992?
Provide a short and direct response. 0.94. What is the ratio of the Aid flow (current US$) in Denmark in 1988 to that in 1992?
Ensure brevity in your answer.  0.42. What is the ratio of the Aid flow (current US$) of Korea in 1988 to that in 1992?
Offer a very short reply. 0.49. What is the ratio of the Aid flow (current US$) of Austria in 1989 to that in 1990?
Your response must be concise. 0.45. What is the ratio of the Aid flow (current US$) of Belgium in 1989 to that in 1990?
Offer a very short reply. 0.92. What is the ratio of the Aid flow (current US$) of Denmark in 1989 to that in 1990?
Provide a short and direct response. 1.35. What is the ratio of the Aid flow (current US$) in Korea in 1989 to that in 1990?
Offer a very short reply. 0.88. What is the ratio of the Aid flow (current US$) in Austria in 1989 to that in 1991?
Your answer should be very brief. 0.31. What is the ratio of the Aid flow (current US$) in Belgium in 1989 to that in 1991?
Your answer should be very brief. 0.64. What is the ratio of the Aid flow (current US$) in Denmark in 1989 to that in 1991?
Your answer should be compact. 1.05. What is the ratio of the Aid flow (current US$) in Korea in 1989 to that in 1991?
Ensure brevity in your answer.  0.42. What is the ratio of the Aid flow (current US$) of Austria in 1989 to that in 1992?
Provide a succinct answer. 0.4. What is the ratio of the Aid flow (current US$) of Belgium in 1989 to that in 1992?
Provide a succinct answer. 0.63. What is the ratio of the Aid flow (current US$) in Denmark in 1989 to that in 1992?
Keep it short and to the point. 1.06. What is the ratio of the Aid flow (current US$) of Korea in 1989 to that in 1992?
Your answer should be very brief. 0.35. What is the ratio of the Aid flow (current US$) in Austria in 1990 to that in 1991?
Offer a terse response. 0.7. What is the ratio of the Aid flow (current US$) of Belgium in 1990 to that in 1991?
Make the answer very short. 0.7. What is the ratio of the Aid flow (current US$) of Denmark in 1990 to that in 1991?
Your response must be concise. 0.78. What is the ratio of the Aid flow (current US$) of Korea in 1990 to that in 1991?
Your answer should be compact. 0.48. What is the ratio of the Aid flow (current US$) of Austria in 1990 to that in 1992?
Make the answer very short. 0.89. What is the ratio of the Aid flow (current US$) of Belgium in 1990 to that in 1992?
Your response must be concise. 0.68. What is the ratio of the Aid flow (current US$) of Denmark in 1990 to that in 1992?
Your answer should be compact. 0.78. What is the ratio of the Aid flow (current US$) of Korea in 1990 to that in 1992?
Ensure brevity in your answer.  0.39. What is the ratio of the Aid flow (current US$) of Austria in 1991 to that in 1992?
Keep it short and to the point. 1.28. What is the ratio of the Aid flow (current US$) in Belgium in 1991 to that in 1992?
Your answer should be very brief. 0.97. What is the ratio of the Aid flow (current US$) of Denmark in 1991 to that in 1992?
Your answer should be compact. 1.01. What is the ratio of the Aid flow (current US$) in Korea in 1991 to that in 1992?
Offer a very short reply. 0.82. What is the difference between the highest and the second highest Aid flow (current US$) in Austria?
Your response must be concise. 2.59e+06. What is the difference between the highest and the second highest Aid flow (current US$) in Denmark?
Provide a short and direct response. 1.54e+06. What is the difference between the highest and the lowest Aid flow (current US$) of Austria?
Ensure brevity in your answer.  9.70e+06. What is the difference between the highest and the lowest Aid flow (current US$) in Belgium?
Your response must be concise. 1.01e+07. What is the difference between the highest and the lowest Aid flow (current US$) of Denmark?
Keep it short and to the point. 2.92e+07. What is the difference between the highest and the lowest Aid flow (current US$) of Korea?
Make the answer very short. 1.19e+07. 